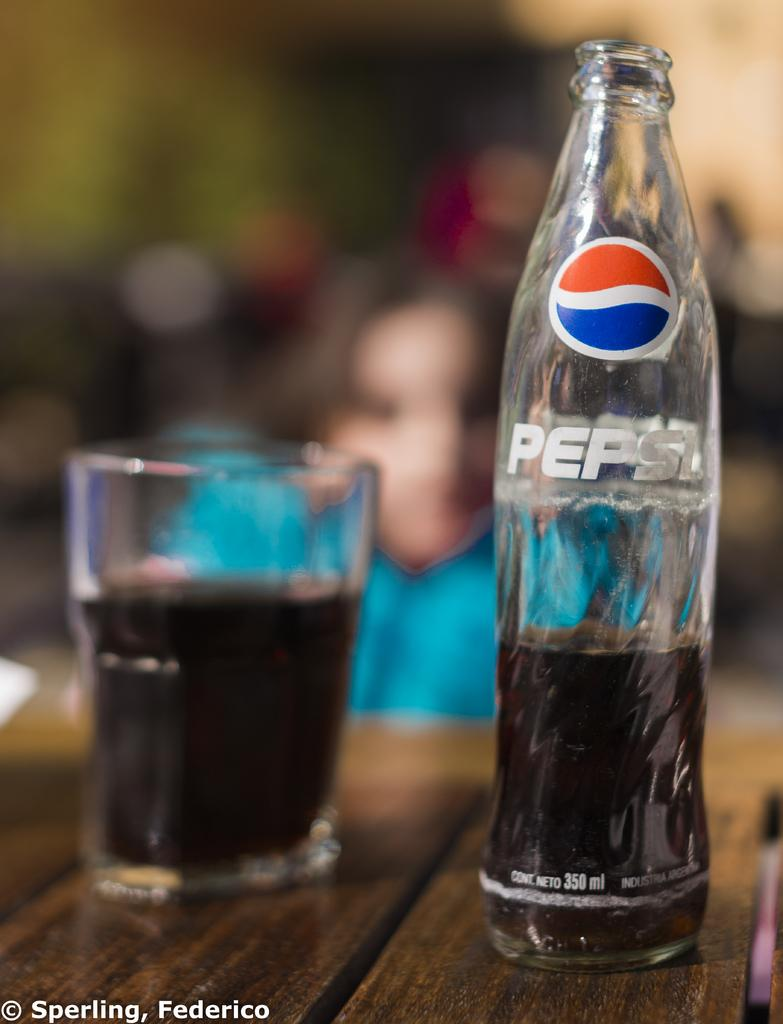<image>
Render a clear and concise summary of the photo. a bottle almost empty with the pepsi label on it 